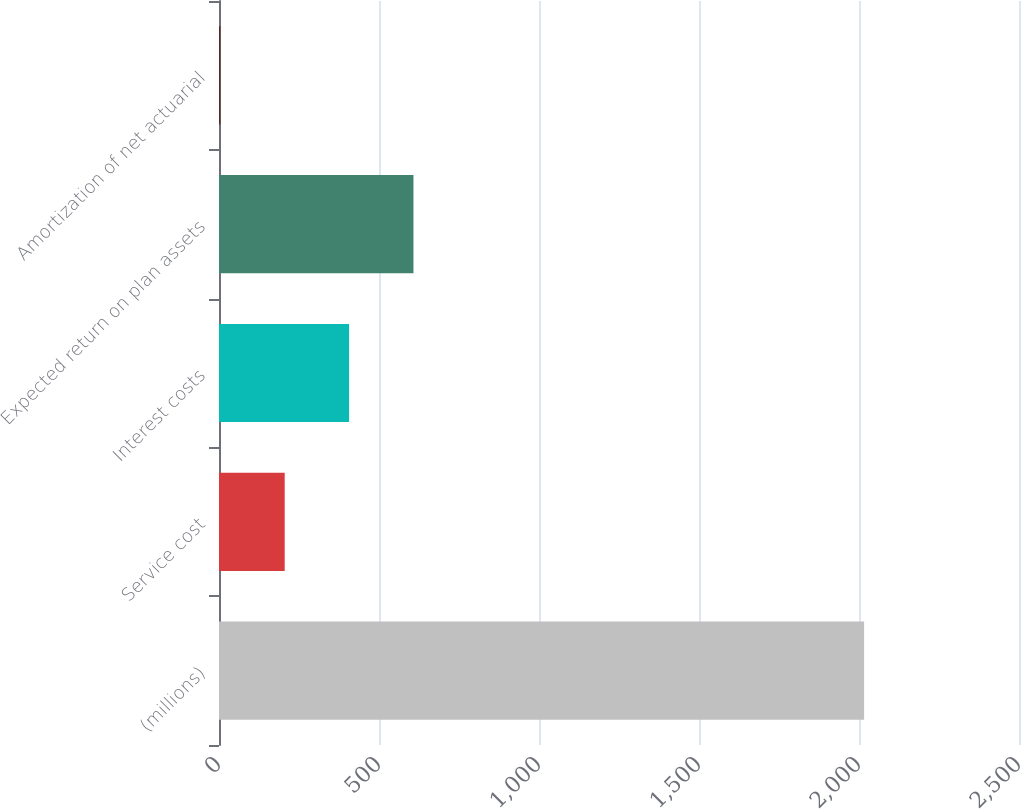<chart> <loc_0><loc_0><loc_500><loc_500><bar_chart><fcel>(millions)<fcel>Service cost<fcel>Interest costs<fcel>Expected return on plan assets<fcel>Amortization of net actuarial<nl><fcel>2016<fcel>205.29<fcel>406.48<fcel>607.67<fcel>4.1<nl></chart> 